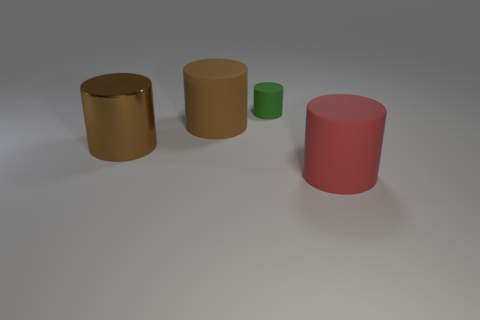Is the big brown cylinder behind the brown metal object made of the same material as the cylinder that is in front of the metallic cylinder?
Your answer should be very brief. Yes. There is a brown object that is made of the same material as the tiny green cylinder; what is its size?
Ensure brevity in your answer.  Large. There is a large object that is on the right side of the green cylinder; what is its shape?
Offer a terse response. Cylinder. There is a cylinder that is in front of the big brown metallic cylinder; is its color the same as the large rubber thing on the left side of the tiny matte thing?
Your answer should be compact. No. What is the size of the thing that is the same color as the shiny cylinder?
Offer a very short reply. Large. Are there any red rubber objects?
Make the answer very short. Yes. There is a big rubber thing behind the brown object that is to the left of the rubber cylinder that is left of the tiny green matte cylinder; what is its shape?
Your response must be concise. Cylinder. There is a brown metallic cylinder; what number of cylinders are in front of it?
Your response must be concise. 1. Do the large cylinder on the right side of the small green object and the green object have the same material?
Your answer should be compact. Yes. There is a big rubber cylinder behind the big rubber thing that is on the right side of the tiny rubber object; how many big brown metal things are behind it?
Your response must be concise. 0. 